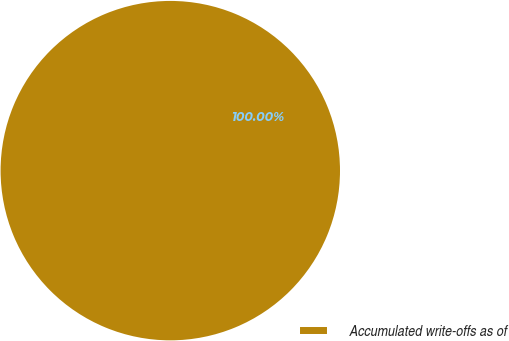Convert chart. <chart><loc_0><loc_0><loc_500><loc_500><pie_chart><fcel>Accumulated write-offs as of<nl><fcel>100.0%<nl></chart> 